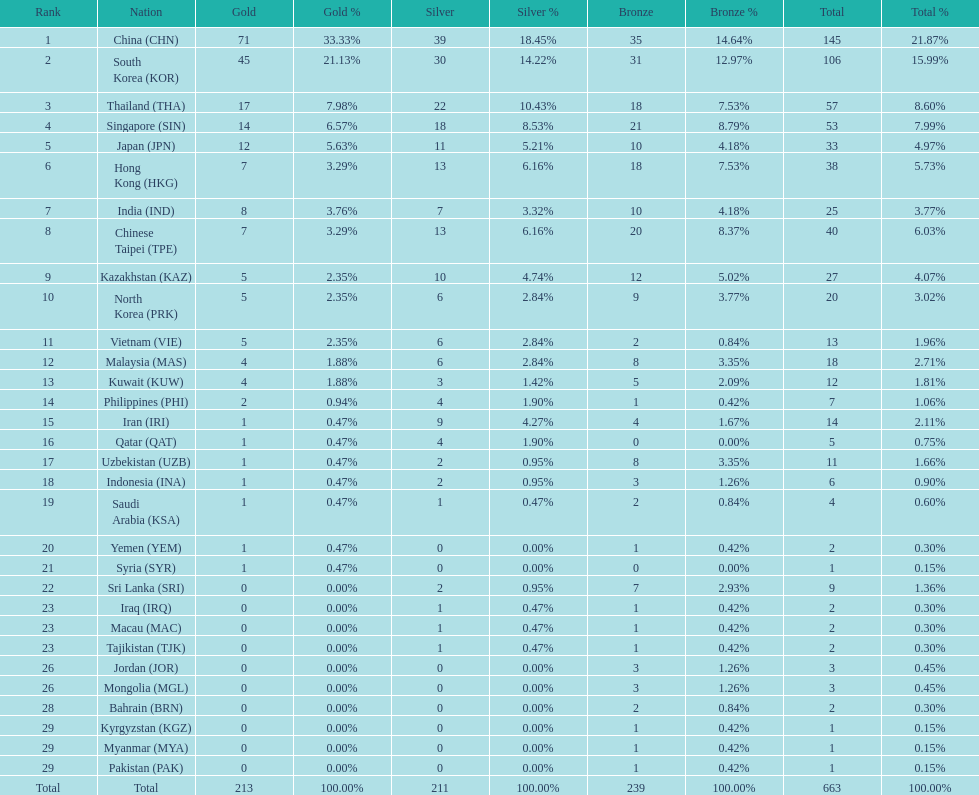What is the total number of medals that india won in the asian youth games? 25. 